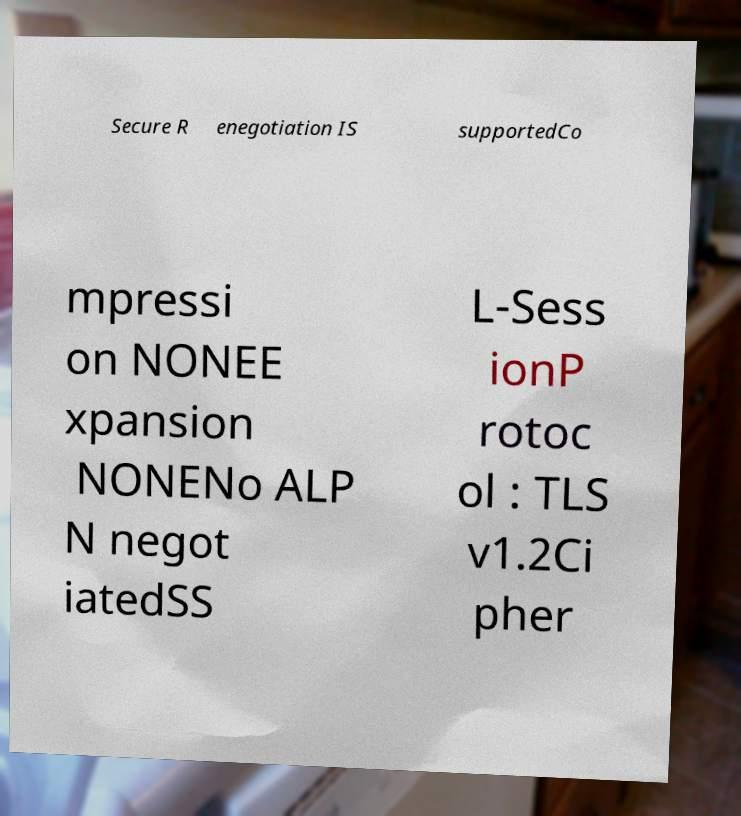What messages or text are displayed in this image? I need them in a readable, typed format. Secure R enegotiation IS supportedCo mpressi on NONEE xpansion NONENo ALP N negot iatedSS L-Sess ionP rotoc ol : TLS v1.2Ci pher 